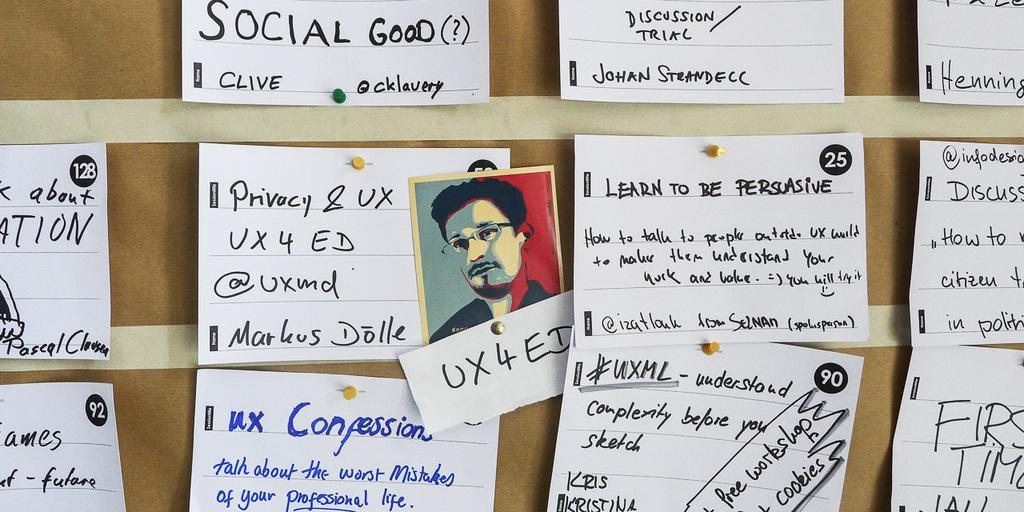What is written on the piece of paper in the image? The provided facts do not specify the content of the text on the paper. What is the color of the cardboard that the paper is placed on? The cardboard is brown in color. Can you describe the photo present in the image? There is a passport size photo of a man in the image. What type of cream is being used to write the text on the paper? There is no cream mentioned or visible in the image; the text is likely written with ink or another writing instrument. What is the name of the man in the passport size photo? The provided facts do not include the name of the man in the photo. 